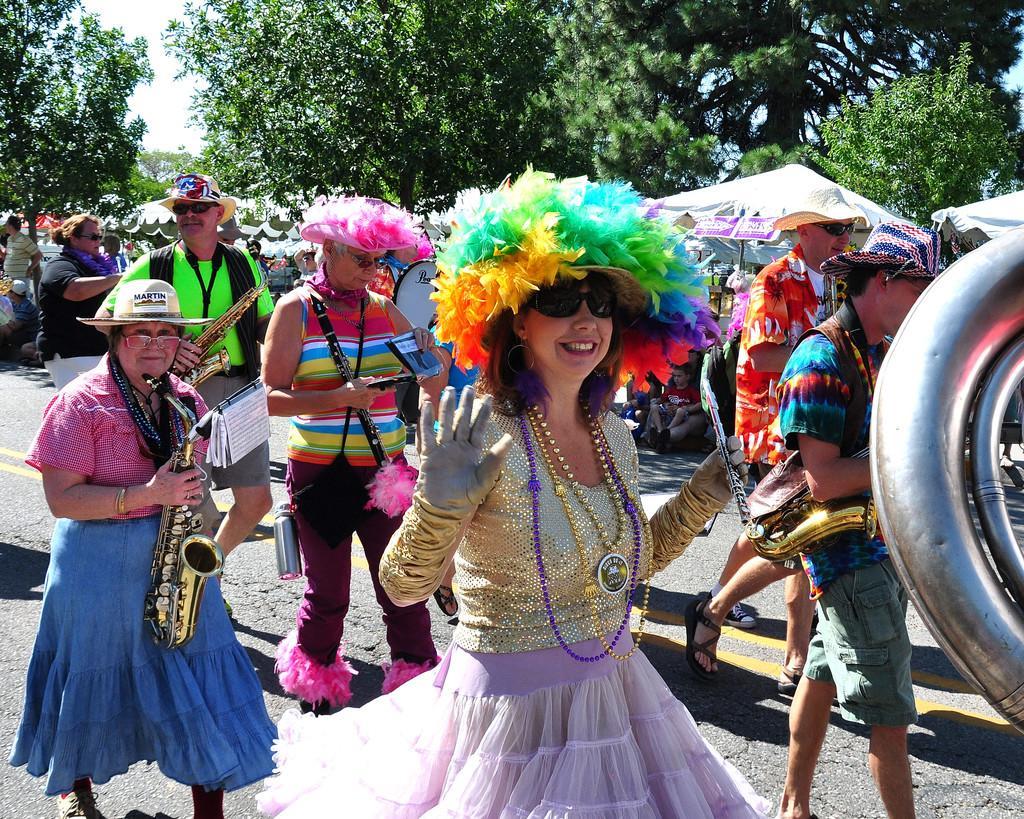Describe this image in one or two sentences. The image is taken on streets of a city. In the foreground of the picture there are people walking on the road, they are wearing different costumes and playing musical instruments. In the center of the picture there are umbrellas, canopy and people. In the background there are trees and sky. 